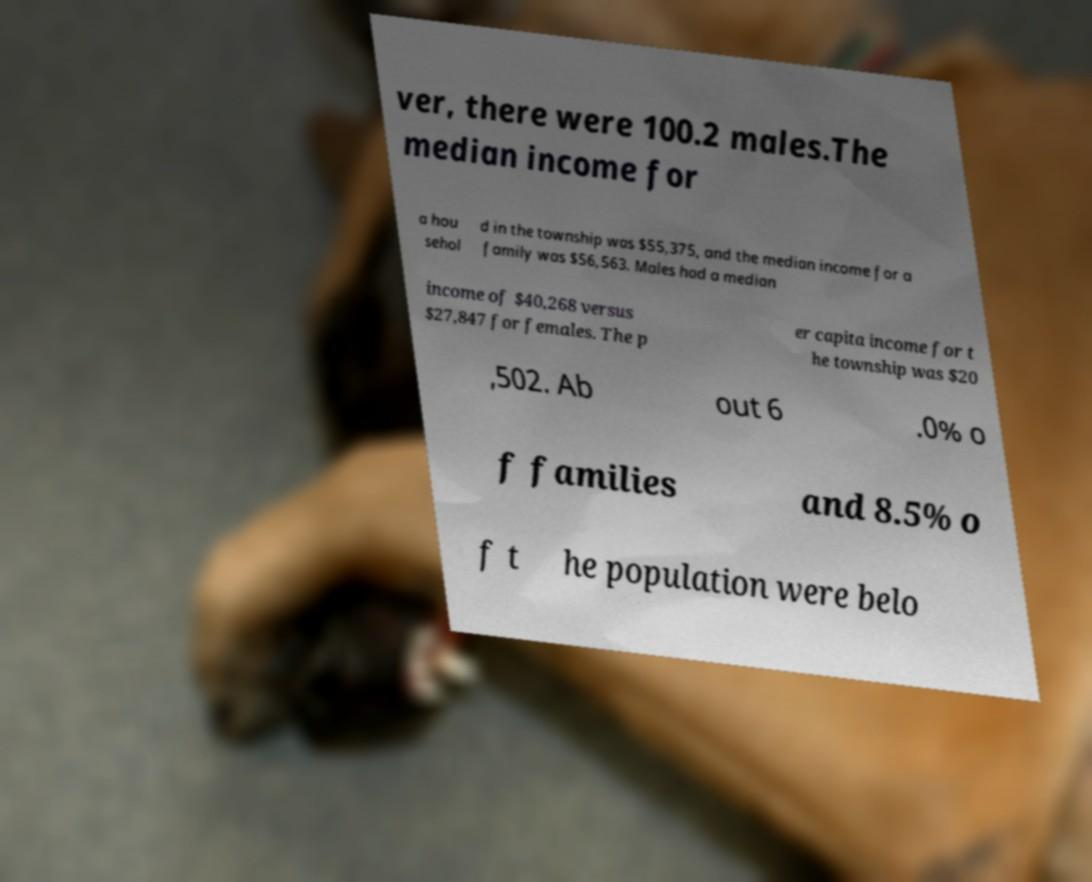Can you accurately transcribe the text from the provided image for me? ver, there were 100.2 males.The median income for a hou sehol d in the township was $55,375, and the median income for a family was $56,563. Males had a median income of $40,268 versus $27,847 for females. The p er capita income for t he township was $20 ,502. Ab out 6 .0% o f families and 8.5% o f t he population were belo 